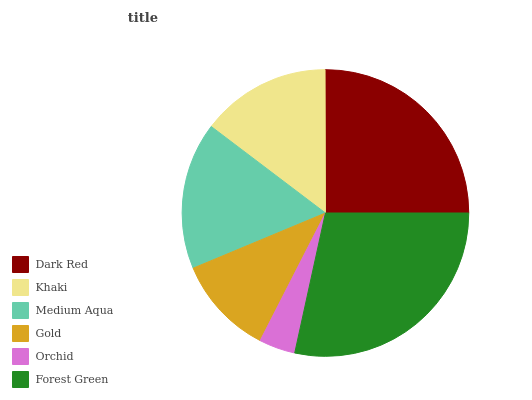Is Orchid the minimum?
Answer yes or no. Yes. Is Forest Green the maximum?
Answer yes or no. Yes. Is Khaki the minimum?
Answer yes or no. No. Is Khaki the maximum?
Answer yes or no. No. Is Dark Red greater than Khaki?
Answer yes or no. Yes. Is Khaki less than Dark Red?
Answer yes or no. Yes. Is Khaki greater than Dark Red?
Answer yes or no. No. Is Dark Red less than Khaki?
Answer yes or no. No. Is Medium Aqua the high median?
Answer yes or no. Yes. Is Khaki the low median?
Answer yes or no. Yes. Is Forest Green the high median?
Answer yes or no. No. Is Orchid the low median?
Answer yes or no. No. 